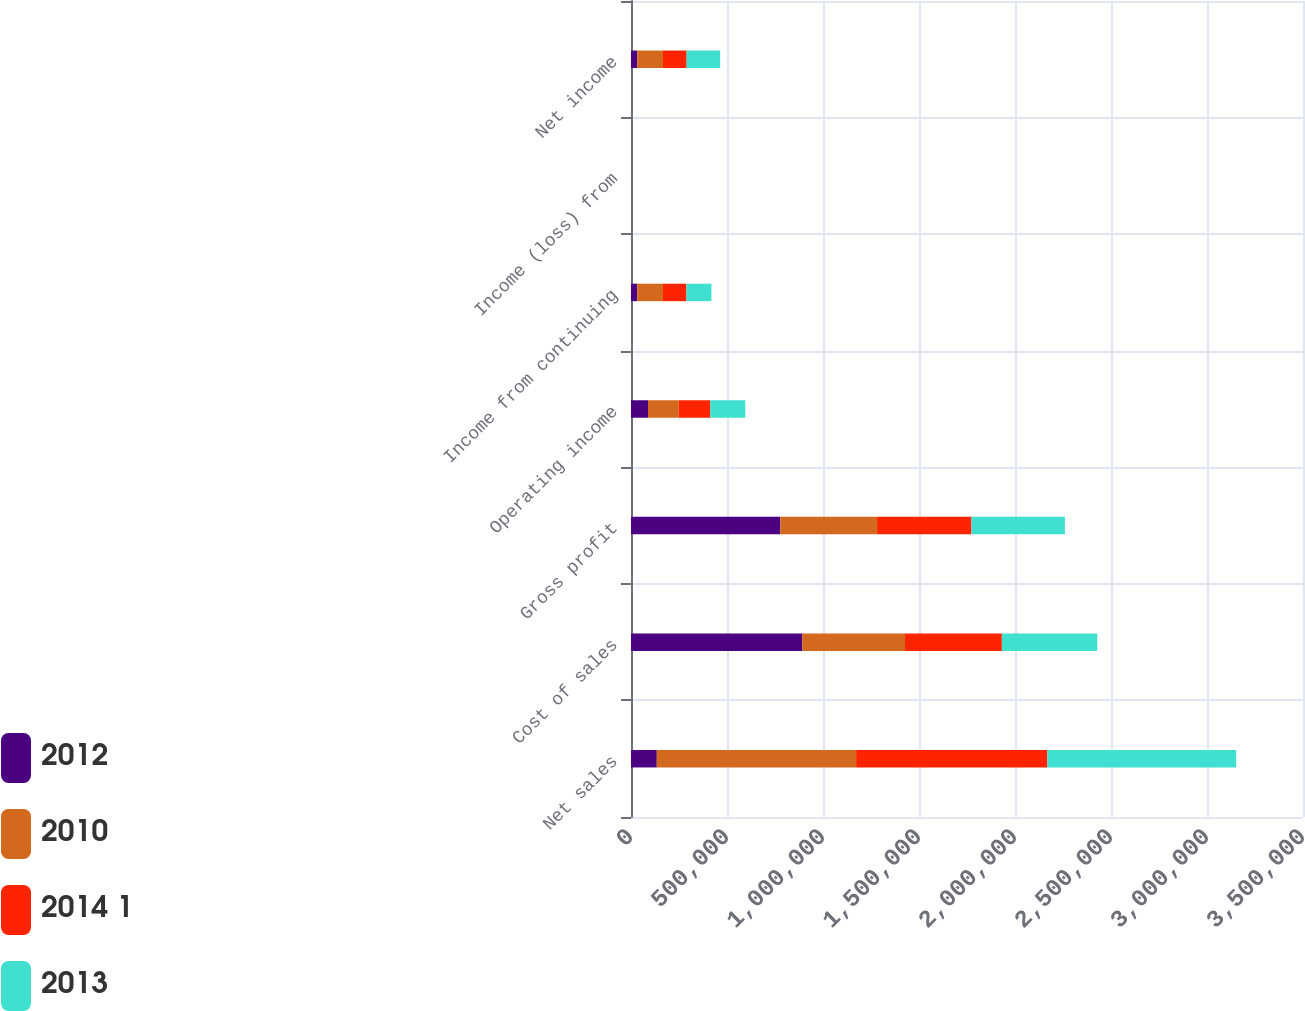Convert chart. <chart><loc_0><loc_0><loc_500><loc_500><stacked_bar_chart><ecel><fcel>Net sales<fcel>Cost of sales<fcel>Gross profit<fcel>Operating income<fcel>Income from continuing<fcel>Income (loss) from<fcel>Net income<nl><fcel>2012<fcel>134358<fcel>892547<fcel>778025<fcel>88590<fcel>32429<fcel>0<fcel>32429<nl><fcel>2010<fcel>1.03816e+06<fcel>534549<fcel>503610<fcel>160264<fcel>134225<fcel>0<fcel>134358<nl><fcel>2014 1<fcel>996168<fcel>504524<fcel>491644<fcel>164351<fcel>121897<fcel>0.02<fcel>122904<nl><fcel>2013<fcel>983488<fcel>496719<fcel>486769<fcel>182036<fcel>130343<fcel>0.82<fcel>174643<nl></chart> 